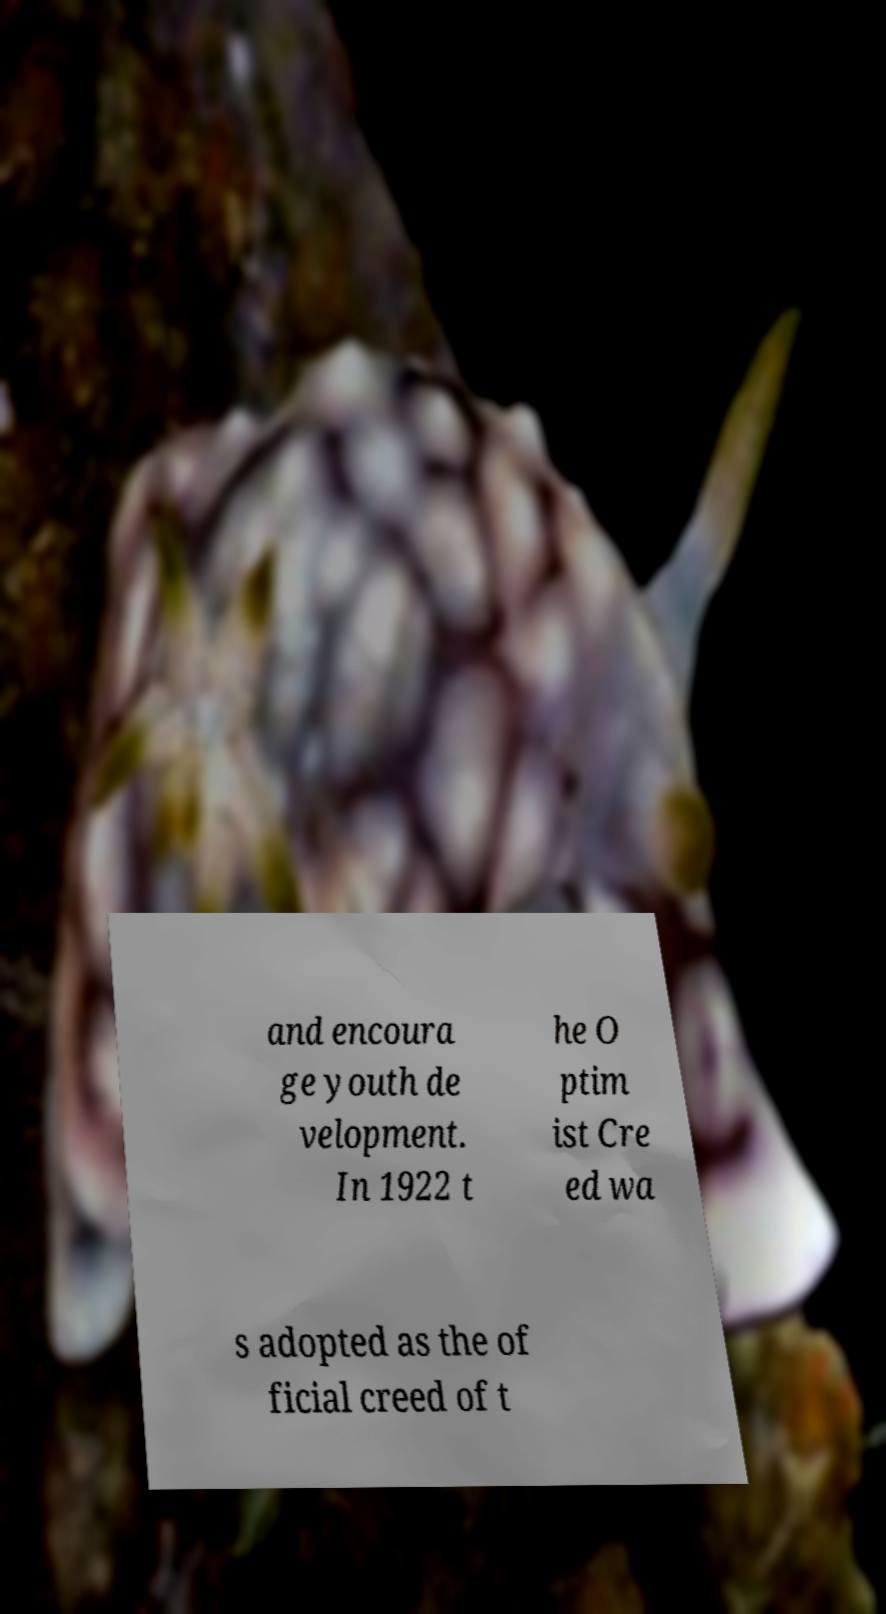What messages or text are displayed in this image? I need them in a readable, typed format. and encoura ge youth de velopment. In 1922 t he O ptim ist Cre ed wa s adopted as the of ficial creed of t 